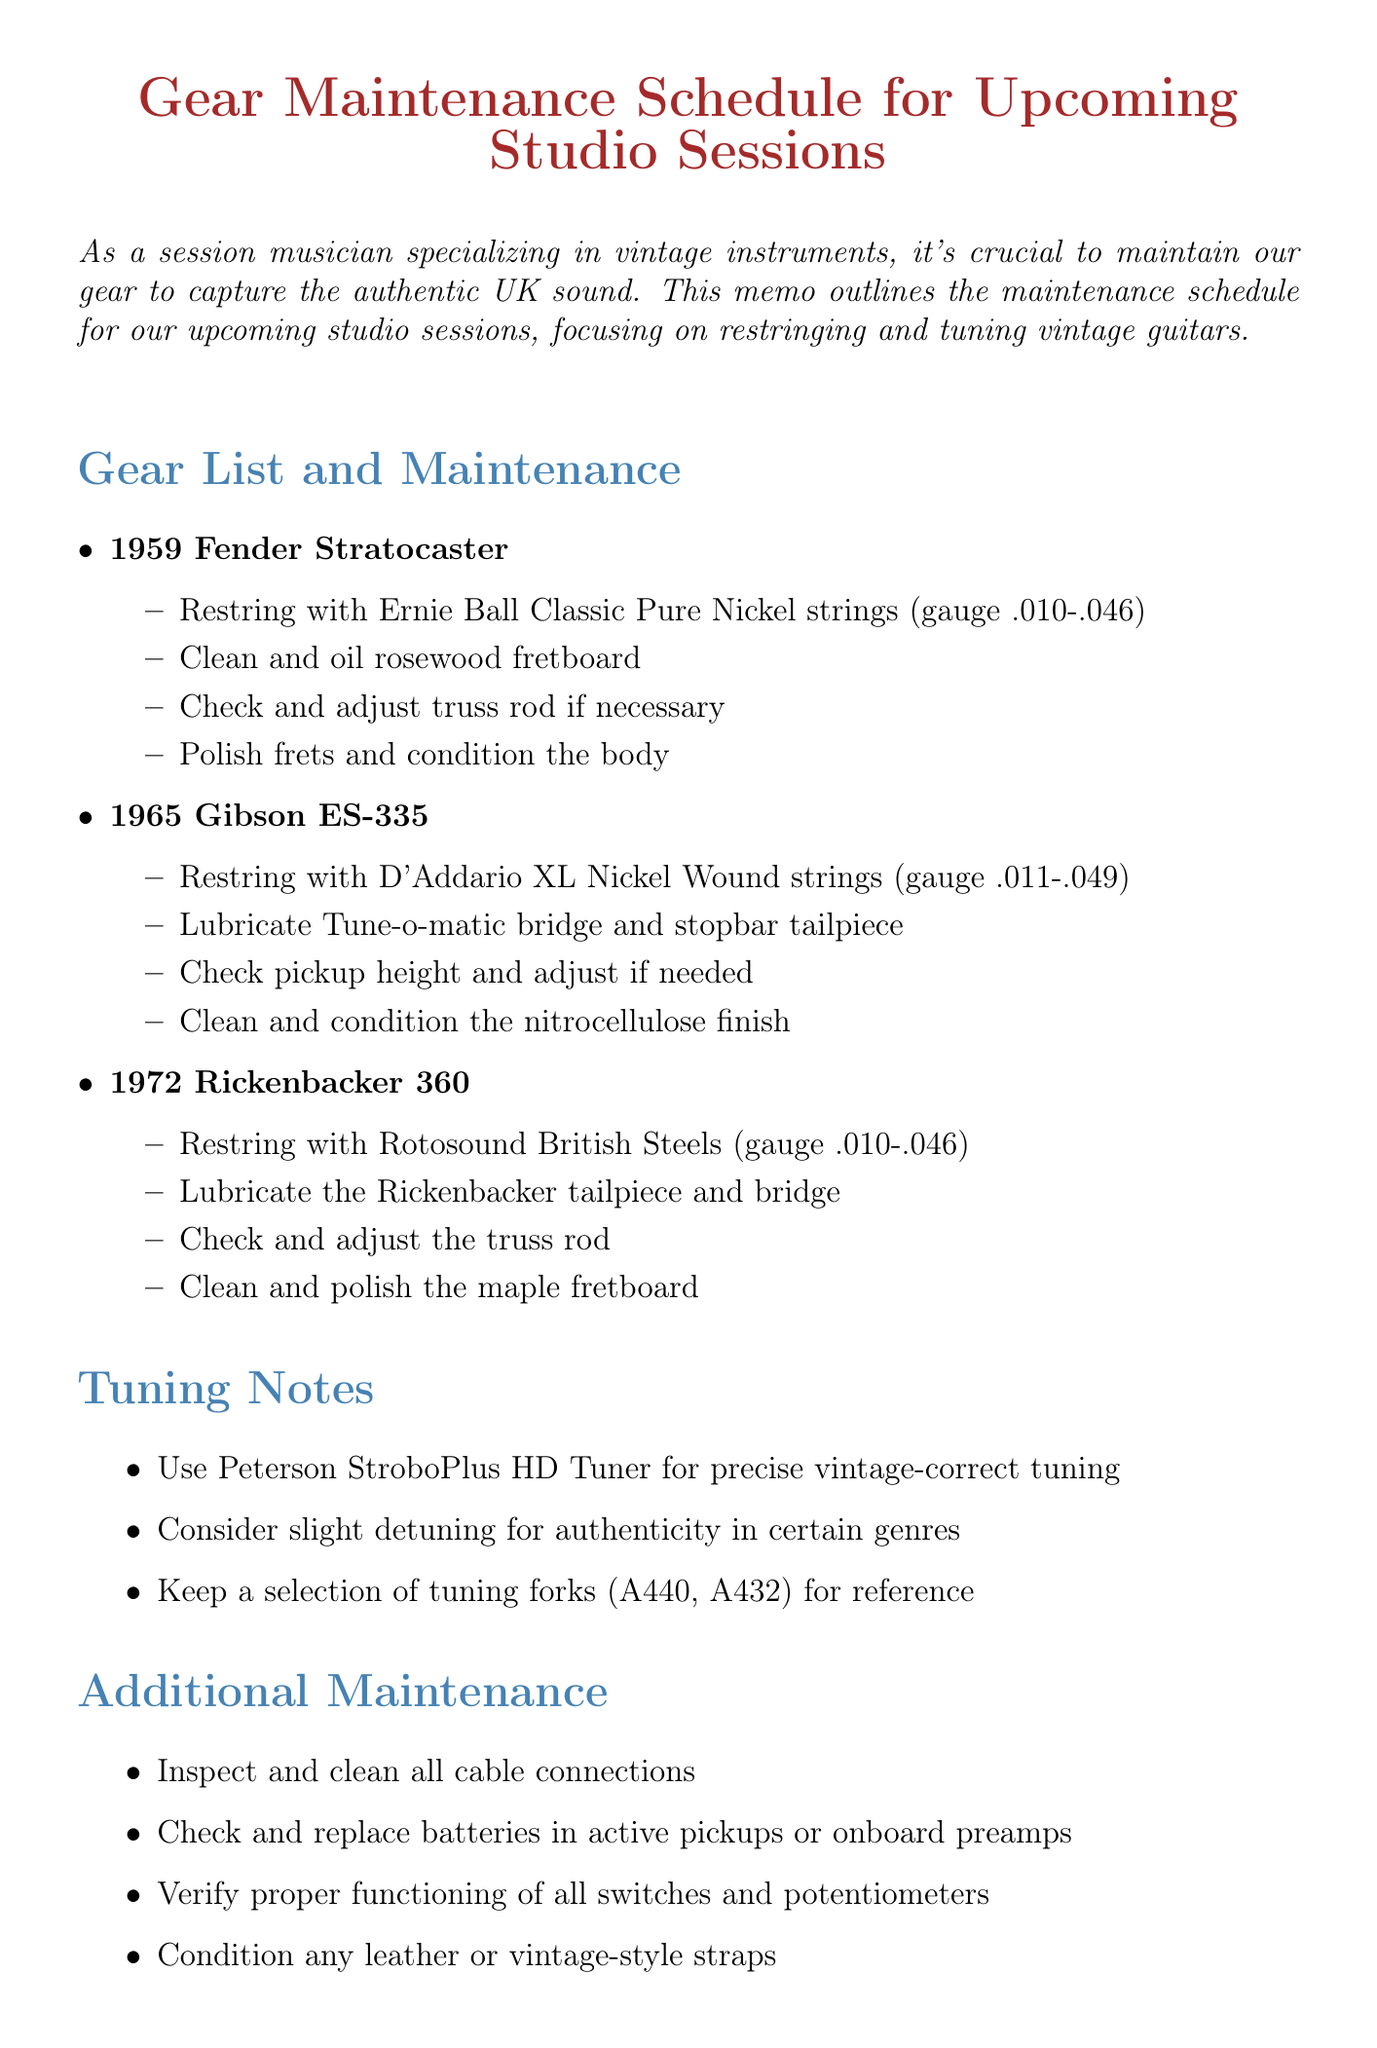What is the title of the memo? The title is explicitly stated at the top of the document for clear reference.
Answer: Gear Maintenance Schedule for Upcoming Studio Sessions How many vintage guitars are listed for maintenance? The number of guitars is determined by counting the items listed under the "Gear List and Maintenance" section.
Answer: 3 What brand of strings is recommended for the 1959 Fender Stratocaster? The specific brand of strings is mentioned in the maintenance list for that guitar.
Answer: Ernie Ball Classic Pure Nickel Which tuner is suggested for precise tuning? The recommended tuner is noted in the "Tuning Notes" section of the memo.
Answer: Peterson StroboPlus HD Tuner What additional equipment should be brought for studio preparation? The studio preparation list details the specific equipment to verify readiness for sessions.
Answer: Vox AC30 amplifier What should be checked and adjusted for the 1965 Gibson ES-335? This action is explicitly stated in the maintenance instructions for that particular guitar.
Answer: Pickup height What is a suggested tuning fork frequency for reference? The tuning forks listed indicate the specific frequencies mentioned in the "Tuning Notes."
Answer: A440 How should the leather straps be maintained? The maintenance recommendations provide clear instructions on the care of the straps.
Answer: Condition any leather or vintage-style straps 